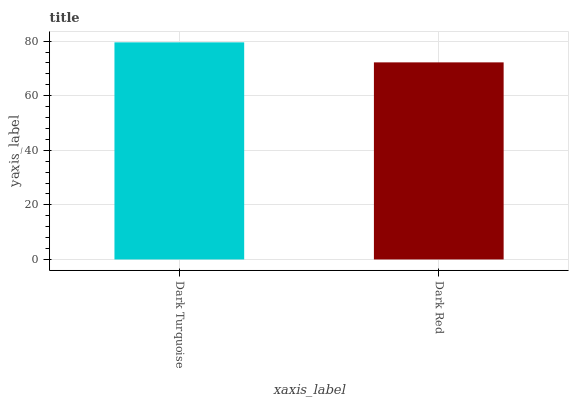Is Dark Red the minimum?
Answer yes or no. Yes. Is Dark Turquoise the maximum?
Answer yes or no. Yes. Is Dark Red the maximum?
Answer yes or no. No. Is Dark Turquoise greater than Dark Red?
Answer yes or no. Yes. Is Dark Red less than Dark Turquoise?
Answer yes or no. Yes. Is Dark Red greater than Dark Turquoise?
Answer yes or no. No. Is Dark Turquoise less than Dark Red?
Answer yes or no. No. Is Dark Turquoise the high median?
Answer yes or no. Yes. Is Dark Red the low median?
Answer yes or no. Yes. Is Dark Red the high median?
Answer yes or no. No. Is Dark Turquoise the low median?
Answer yes or no. No. 